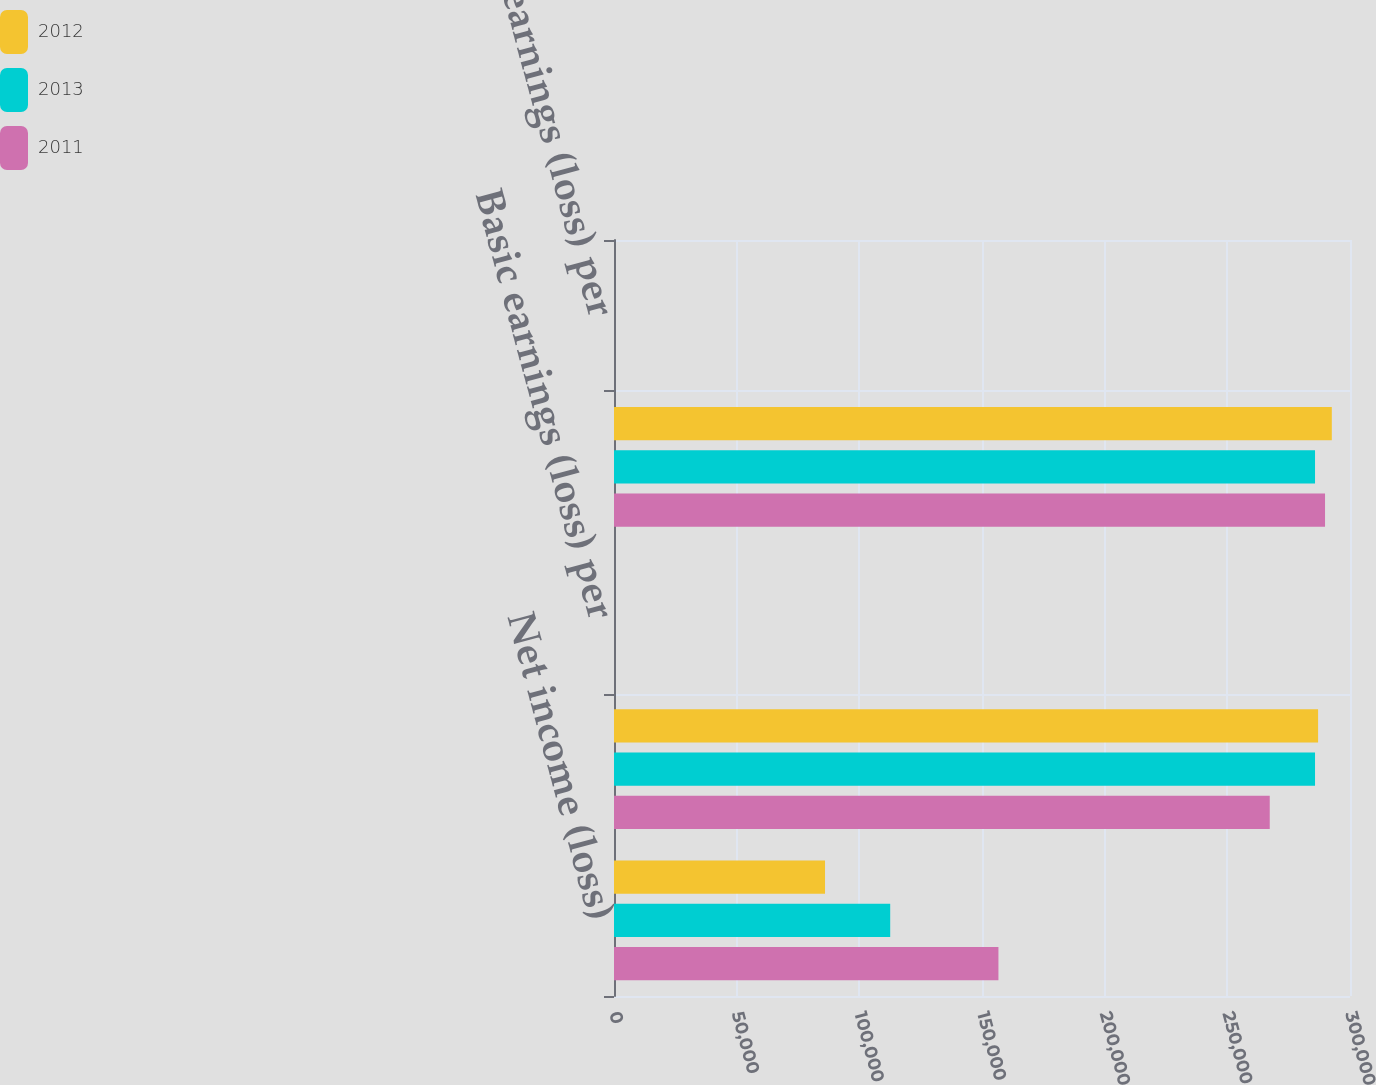Convert chart. <chart><loc_0><loc_0><loc_500><loc_500><stacked_bar_chart><ecel><fcel>Net income (loss)<fcel>Basic weighted-average shares<fcel>Basic earnings (loss) per<fcel>Diluted weighted-average<fcel>Diluted earnings (loss) per<nl><fcel>2012<fcel>86012<fcel>286991<fcel>0.3<fcel>292589<fcel>0.29<nl><fcel>2013<fcel>112583<fcel>285748<fcel>0.39<fcel>285748<fcel>0.39<nl><fcel>2011<fcel>156701<fcel>267291<fcel>0.59<fcel>289822<fcel>0.54<nl></chart> 